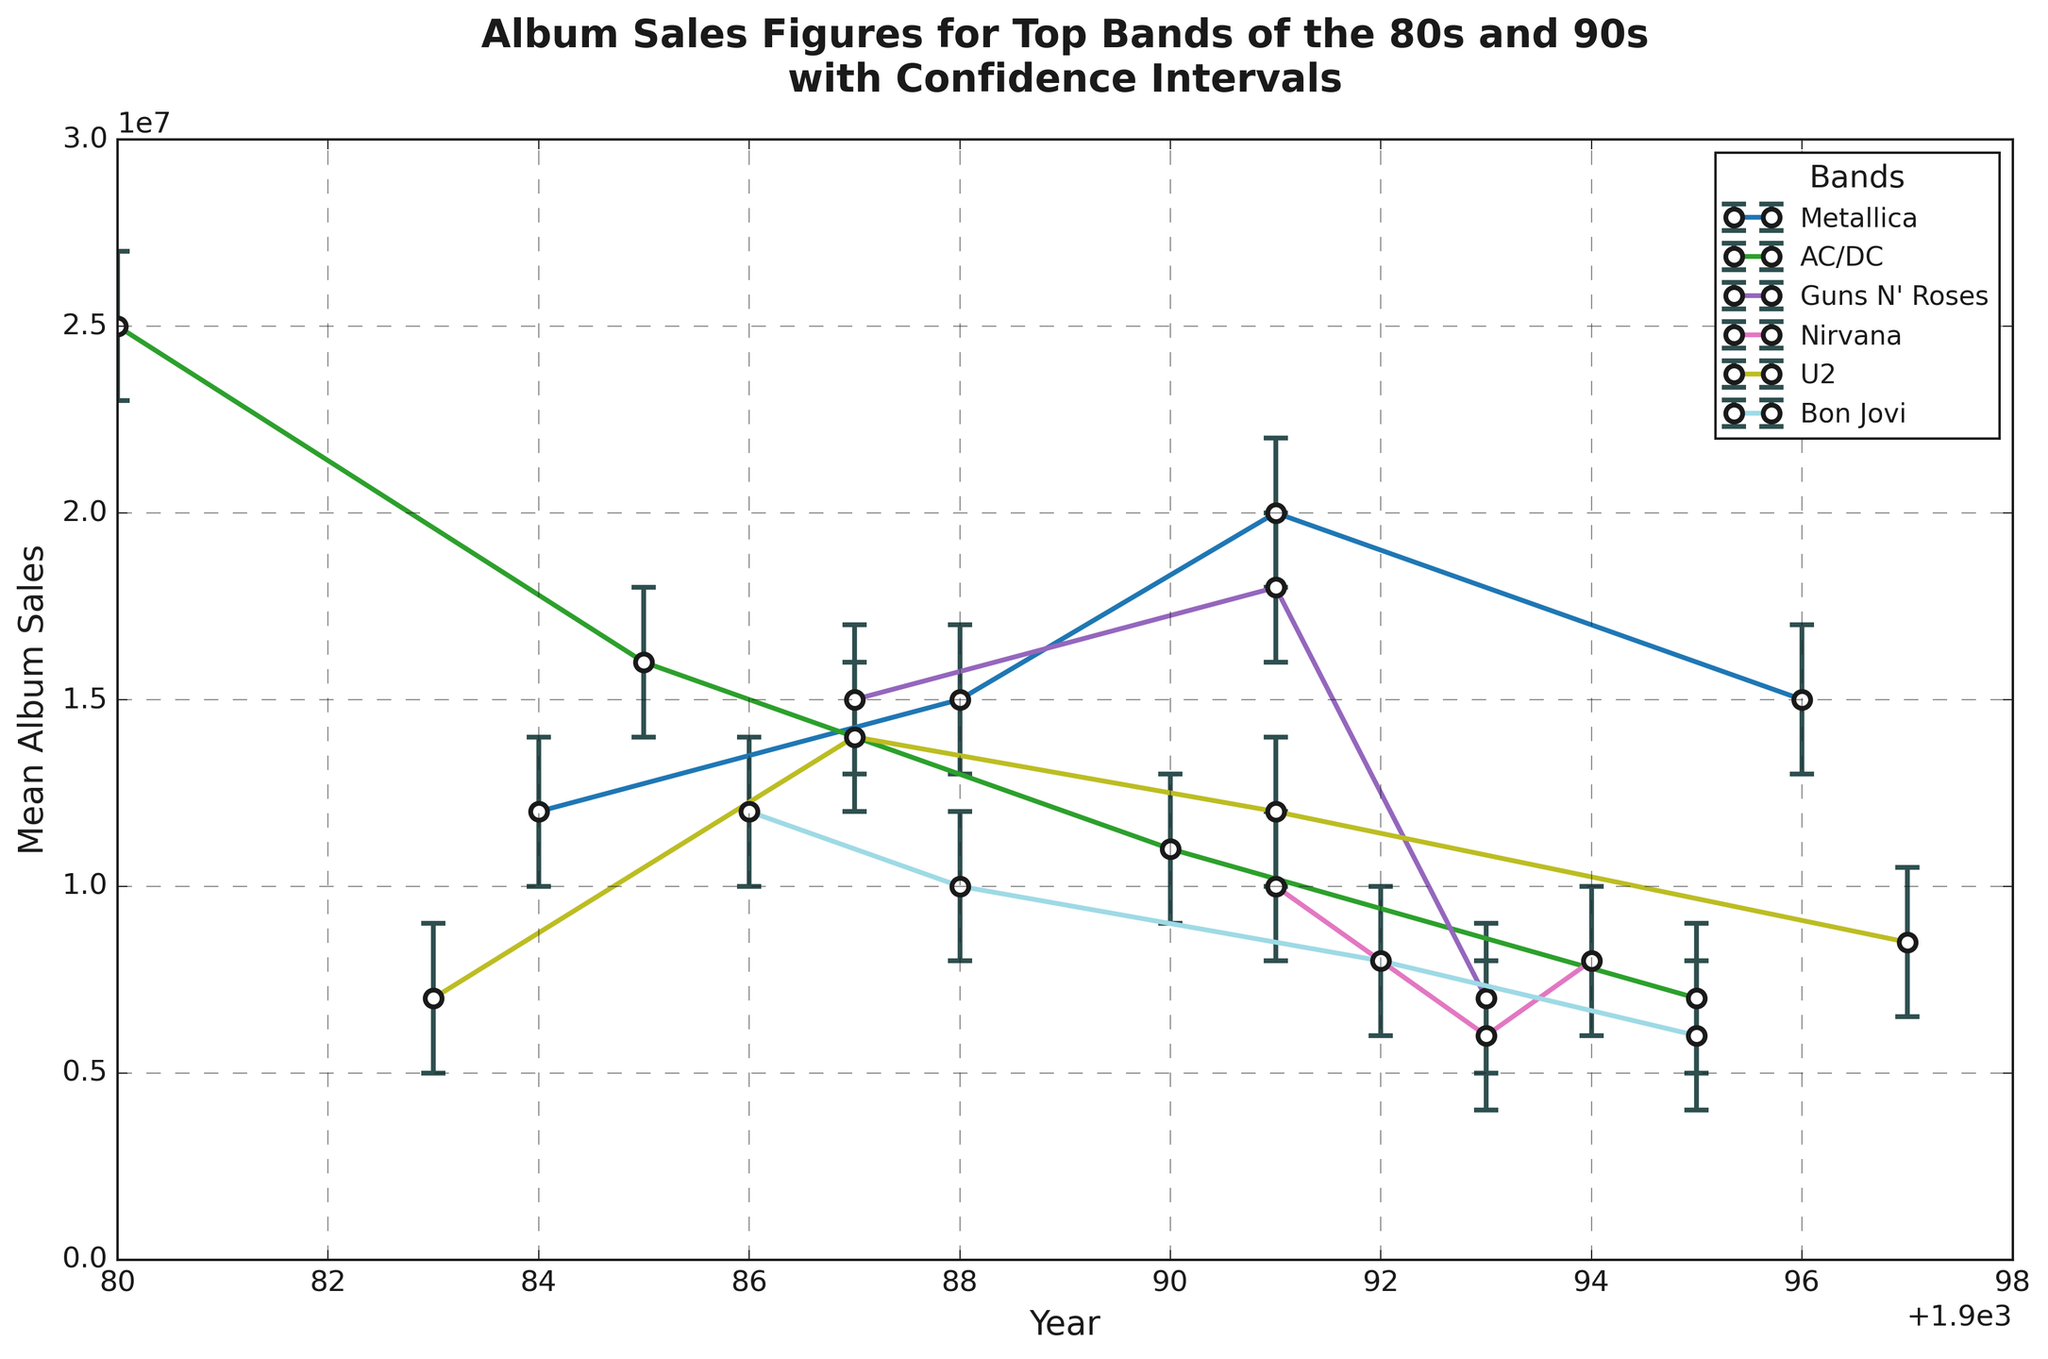What's the trend of Metallica's album sales from 1984 to 1996? Metallica's album sales increased from 12,000,000 in 1984 to 20,000,000 in 1991, then dropped to 15,000,000 in 1996. This can be observed by following the points corresponding to Metallica and seeing the ascending sales until 1991 and subsequent drop in 1996.
Answer: Increased, then decreased Which band had the highest album sales figure in 1980? In 1980, AC/DC had the highest album sales figure of 25,000,000, as shown by the highest point for that year.
Answer: AC/DC Compare AC/DC's album sales in 1985 and 1995. What is the difference? AC/DC's album sales were 16,000,000 in 1985 and 7,000,000 in 1995. The difference is 16,000,000 - 7,000,000 = 9,000,000.
Answer: 9,000,000 Which band showed a sharp decrease in album sales between two consecutive data points, and what were the years? Guns N' Roses showed a sharp decrease in album sales between 1991 and 1993, dropping from 18,000,000 to 7,000,000. This is observed by the largest quick drop.
Answer: Guns N' Roses, 1991 to 1993 What is the average album sales figure for Nirvana across all years presented? Nirvana's album sales figures are 10,000,000 (1991), 6,000,000 (1993), and 8,000,000 (1994). The average is (10,000,000 + 6,000,000 + 8,000,000) / 3 = 8,000,000.
Answer: 8,000,000 Which band had the most consistent sales figures (least fluctuation) and how do you know? U2 had the most consistent album sales with figures ranging between 6,000,000 and 14,000,000 from 1983 to 1997, which has the smallest range compared to other bands.
Answer: U2 Did any band reach album sales of 20,000,000 or more in any given year, and if so, which bands and years? Yes, AC/DC in 1980 (25,000,000) and Metallica in 1991 (20,000,000). These can be seen as the highest points on the graph reaching or exceeding 20,000,000.
Answer: AC/DC 1980, Metallica 1991 Which two bands had the highest mean album sales across the years, and what are their values? AC/DC and Metallica. AC/DC's years are 25,000,000 (1980), 16,000,000 (1985), 11,000,000 (1990), and 7,000,000 (1995), averaging to (25,000,000 + 16,000,000 + 11,000,000 + 7,000,000) / 4 = 14,750,000. Metallica's years are 12,000,000 (1984), 15,000,000 (1988), 20,000,000 (1991), 15,000,000 (1996), averaging to (12,000,000 + 15,000,000 + 20,000,000 + 15,000,000) / 4 = 15,500,000.
Answer: Metallica: 15,500,000, AC/DC: 14,750,000 